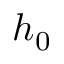<formula> <loc_0><loc_0><loc_500><loc_500>h _ { 0 }</formula> 